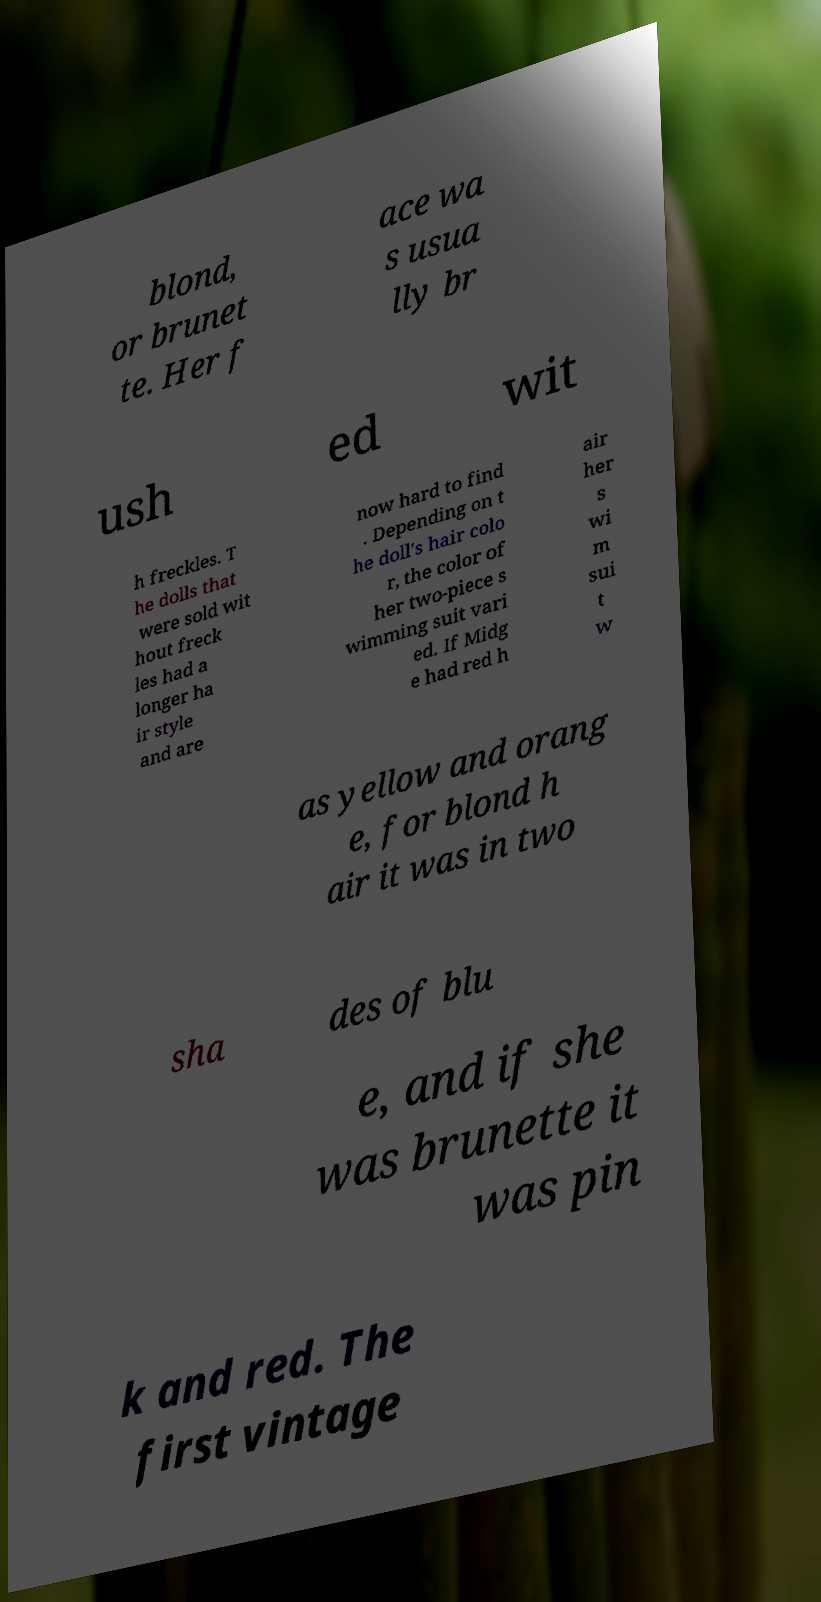I need the written content from this picture converted into text. Can you do that? blond, or brunet te. Her f ace wa s usua lly br ush ed wit h freckles. T he dolls that were sold wit hout freck les had a longer ha ir style and are now hard to find . Depending on t he doll's hair colo r, the color of her two-piece s wimming suit vari ed. If Midg e had red h air her s wi m sui t w as yellow and orang e, for blond h air it was in two sha des of blu e, and if she was brunette it was pin k and red. The first vintage 